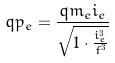<formula> <loc_0><loc_0><loc_500><loc_500>q p _ { e } = \frac { q m _ { e } i _ { e } } { \sqrt { 1 \cdot \frac { i _ { e } ^ { 3 } } { f ^ { 3 } } } }</formula> 